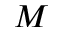<formula> <loc_0><loc_0><loc_500><loc_500>M</formula> 